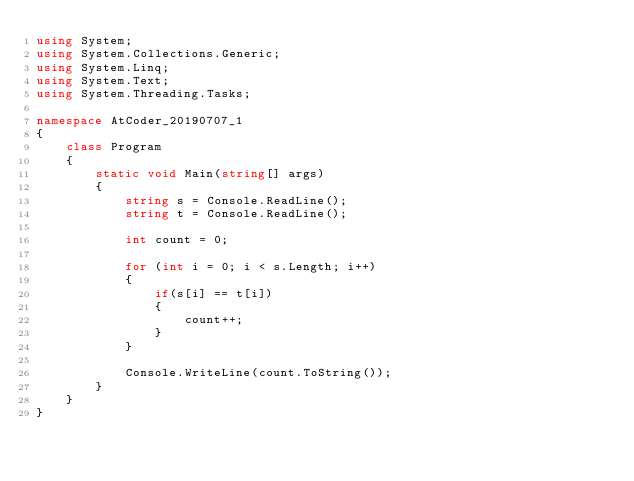<code> <loc_0><loc_0><loc_500><loc_500><_C#_>using System;
using System.Collections.Generic;
using System.Linq;
using System.Text;
using System.Threading.Tasks;

namespace AtCoder_20190707_1
{
    class Program
    {
        static void Main(string[] args)
        {            
            string s = Console.ReadLine();
            string t = Console.ReadLine();

            int count = 0;

            for (int i = 0; i < s.Length; i++)
            {
                if(s[i] == t[i])
                {
                    count++;
                }
            }

            Console.WriteLine(count.ToString());
        }
    }
}
</code> 